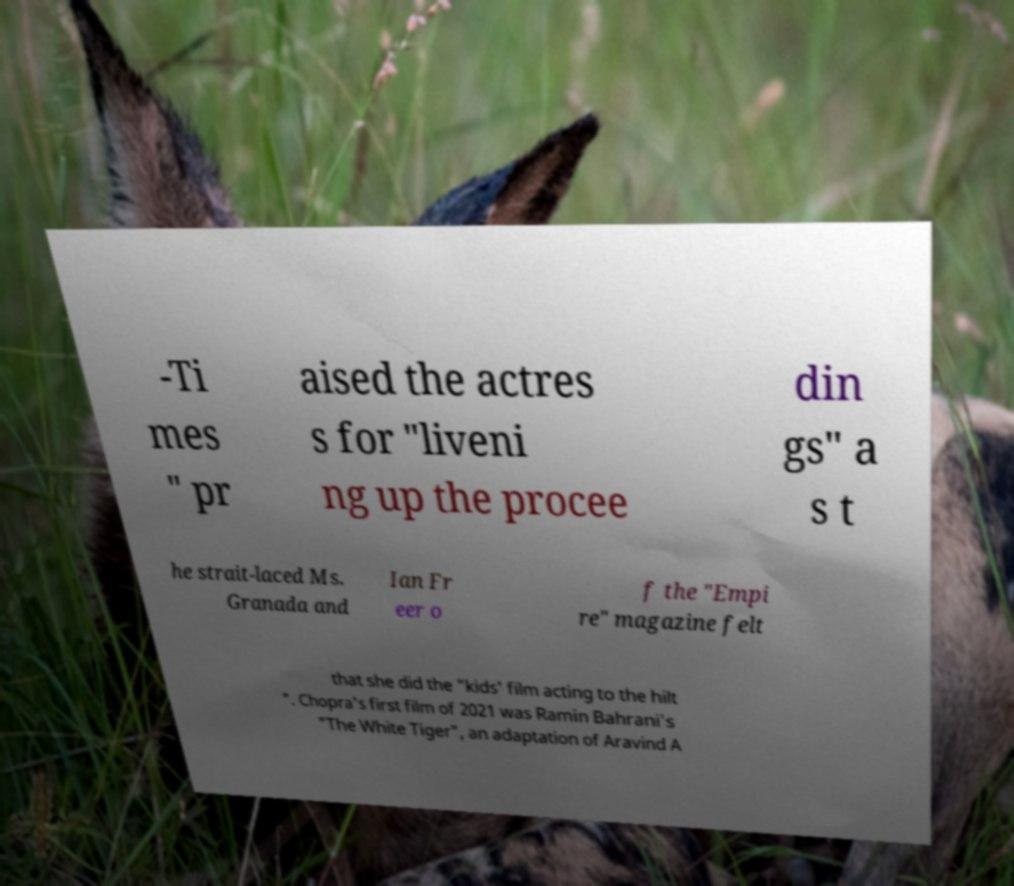I need the written content from this picture converted into text. Can you do that? -Ti mes " pr aised the actres s for "liveni ng up the procee din gs" a s t he strait-laced Ms. Granada and Ian Fr eer o f the "Empi re" magazine felt that she did the "kids' film acting to the hilt ". Chopra's first film of 2021 was Ramin Bahrani's "The White Tiger", an adaptation of Aravind A 